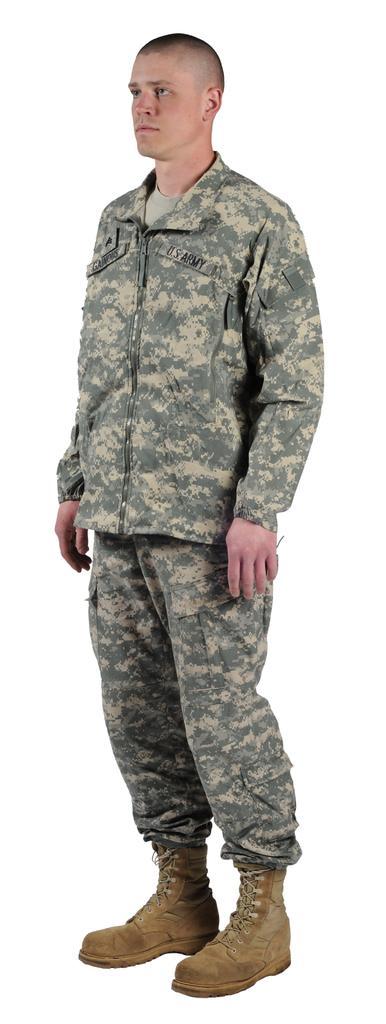Describe this image in one or two sentences. Here I can see a man wearing uniform, shoes and standing facing towards the left side. The background is in white color. 